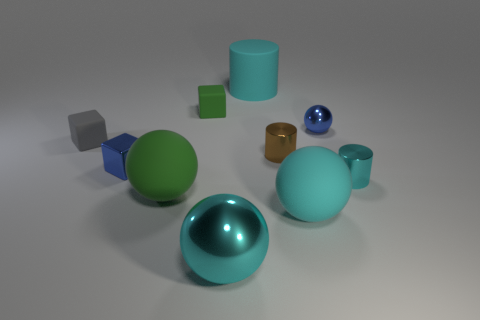How many matte things are either tiny cubes or large cyan balls?
Keep it short and to the point. 3. There is a blue sphere that is the same size as the green rubber block; what is it made of?
Make the answer very short. Metal. How many other things are the same material as the green block?
Offer a terse response. 4. Are there fewer small brown shiny cylinders right of the brown object than small cyan metallic things?
Keep it short and to the point. Yes. Is the big green thing the same shape as the tiny cyan metal thing?
Provide a short and direct response. No. There is a metal ball that is in front of the large matte sphere that is left of the large thing behind the tiny blue cube; how big is it?
Your answer should be compact. Large. There is a green object that is the same shape as the gray rubber thing; what is it made of?
Your response must be concise. Rubber. Is there any other thing that is the same size as the brown metal object?
Offer a very short reply. Yes. What is the size of the green rubber object that is behind the cyan shiny thing right of the matte cylinder?
Keep it short and to the point. Small. The metallic cube is what color?
Ensure brevity in your answer.  Blue. 